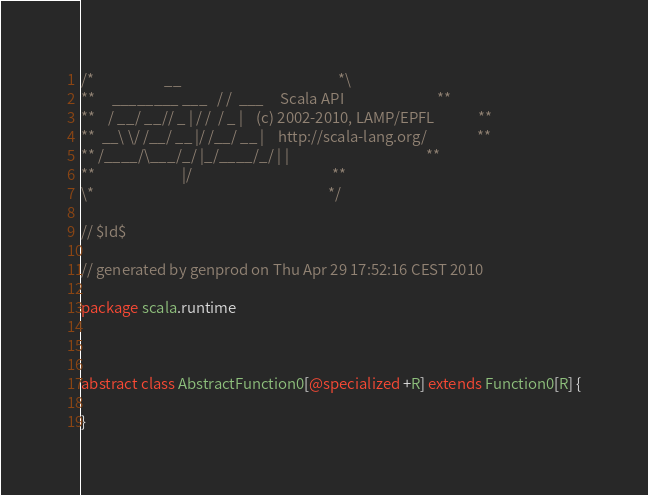Convert code to text. <code><loc_0><loc_0><loc_500><loc_500><_Scala_>/*                     __                                               *\
**     ________ ___   / /  ___     Scala API                            **
**    / __/ __// _ | / /  / _ |    (c) 2002-2010, LAMP/EPFL             **
**  __\ \/ /__/ __ |/ /__/ __ |    http://scala-lang.org/               **
** /____/\___/_/ |_/____/_/ | |                                         **
**                          |/                                          **
\*                                                                      */

// $Id$

// generated by genprod on Thu Apr 29 17:52:16 CEST 2010  

package scala.runtime



abstract class AbstractFunction0[@specialized +R] extends Function0[R] {

}
</code> 